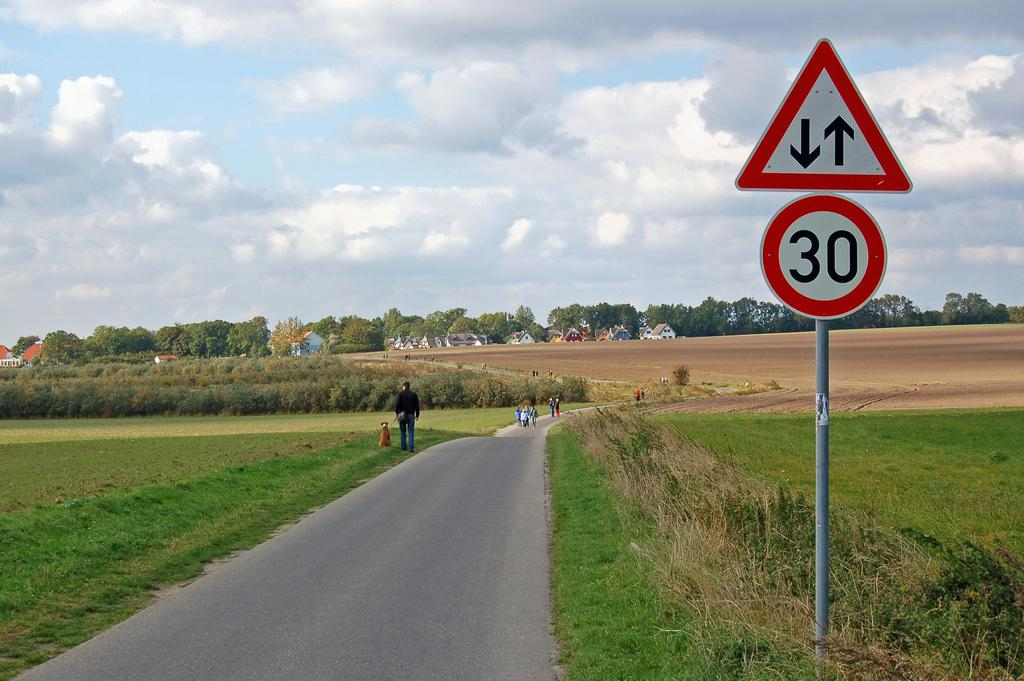<image>
Describe the image concisely. A long road surrounded by grassy fields with a speed limit of 30. 